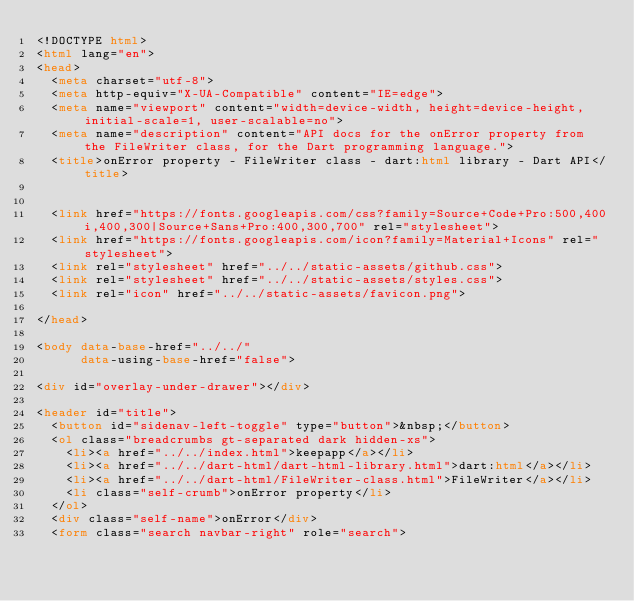Convert code to text. <code><loc_0><loc_0><loc_500><loc_500><_HTML_><!DOCTYPE html>
<html lang="en">
<head>
  <meta charset="utf-8">
  <meta http-equiv="X-UA-Compatible" content="IE=edge">
  <meta name="viewport" content="width=device-width, height=device-height, initial-scale=1, user-scalable=no">
  <meta name="description" content="API docs for the onError property from the FileWriter class, for the Dart programming language.">
  <title>onError property - FileWriter class - dart:html library - Dart API</title>

  
  <link href="https://fonts.googleapis.com/css?family=Source+Code+Pro:500,400i,400,300|Source+Sans+Pro:400,300,700" rel="stylesheet">
  <link href="https://fonts.googleapis.com/icon?family=Material+Icons" rel="stylesheet">
  <link rel="stylesheet" href="../../static-assets/github.css">
  <link rel="stylesheet" href="../../static-assets/styles.css">
  <link rel="icon" href="../../static-assets/favicon.png">

</head>

<body data-base-href="../../"
      data-using-base-href="false">

<div id="overlay-under-drawer"></div>

<header id="title">
  <button id="sidenav-left-toggle" type="button">&nbsp;</button>
  <ol class="breadcrumbs gt-separated dark hidden-xs">
    <li><a href="../../index.html">keepapp</a></li>
    <li><a href="../../dart-html/dart-html-library.html">dart:html</a></li>
    <li><a href="../../dart-html/FileWriter-class.html">FileWriter</a></li>
    <li class="self-crumb">onError property</li>
  </ol>
  <div class="self-name">onError</div>
  <form class="search navbar-right" role="search"></code> 